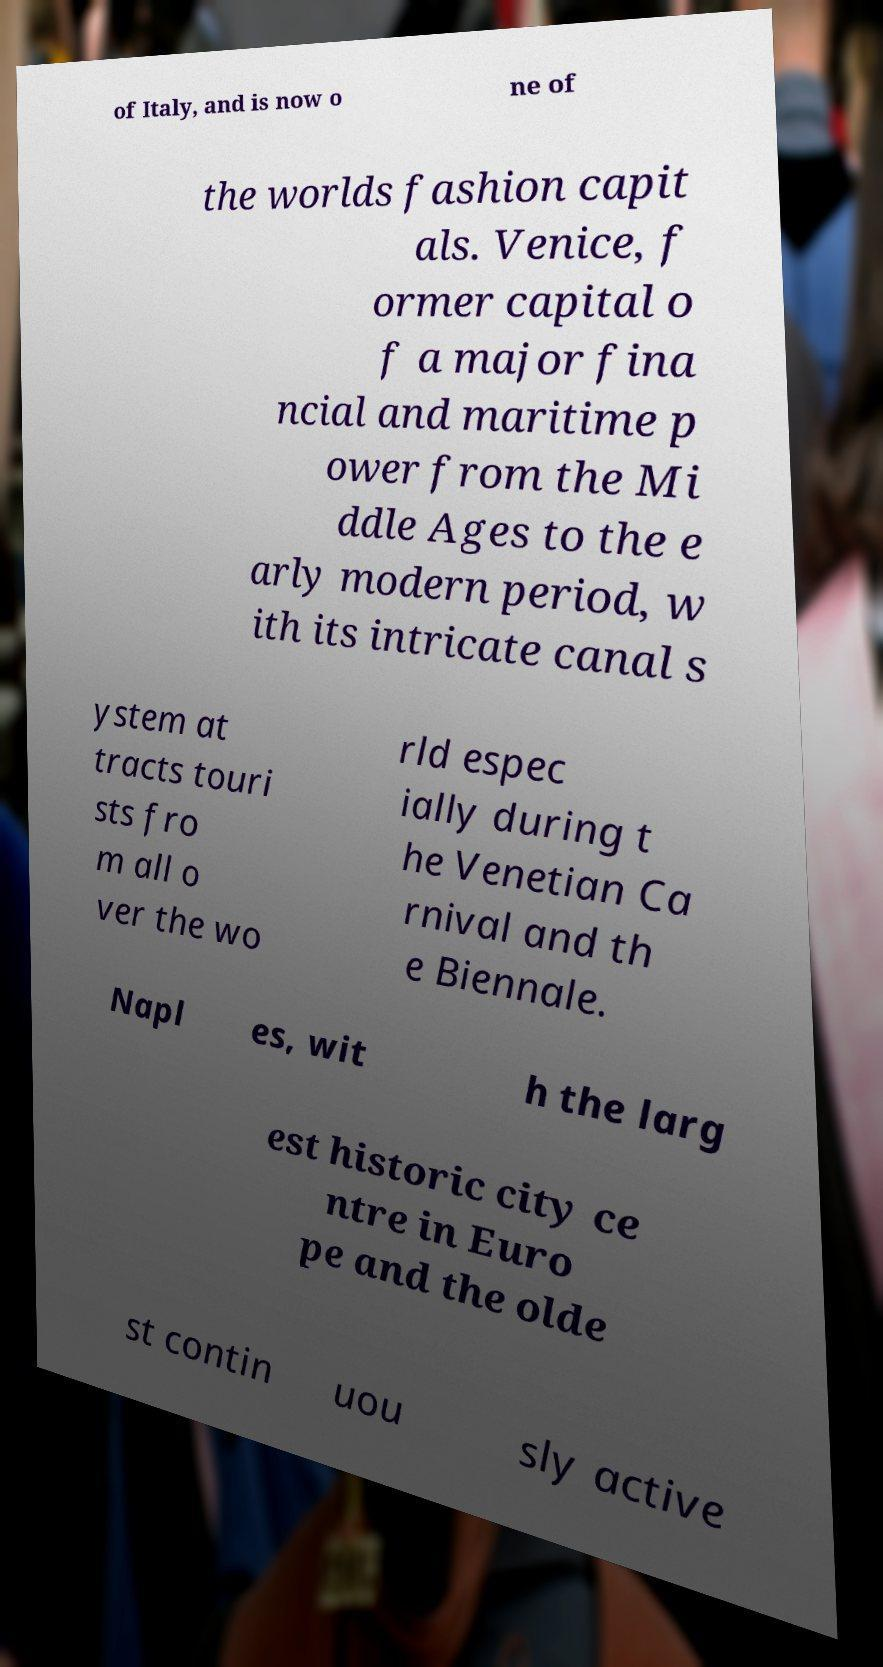Please read and relay the text visible in this image. What does it say? of Italy, and is now o ne of the worlds fashion capit als. Venice, f ormer capital o f a major fina ncial and maritime p ower from the Mi ddle Ages to the e arly modern period, w ith its intricate canal s ystem at tracts touri sts fro m all o ver the wo rld espec ially during t he Venetian Ca rnival and th e Biennale. Napl es, wit h the larg est historic city ce ntre in Euro pe and the olde st contin uou sly active 